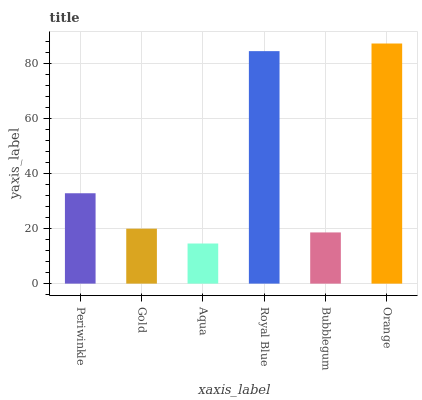Is Aqua the minimum?
Answer yes or no. Yes. Is Orange the maximum?
Answer yes or no. Yes. Is Gold the minimum?
Answer yes or no. No. Is Gold the maximum?
Answer yes or no. No. Is Periwinkle greater than Gold?
Answer yes or no. Yes. Is Gold less than Periwinkle?
Answer yes or no. Yes. Is Gold greater than Periwinkle?
Answer yes or no. No. Is Periwinkle less than Gold?
Answer yes or no. No. Is Periwinkle the high median?
Answer yes or no. Yes. Is Gold the low median?
Answer yes or no. Yes. Is Orange the high median?
Answer yes or no. No. Is Bubblegum the low median?
Answer yes or no. No. 